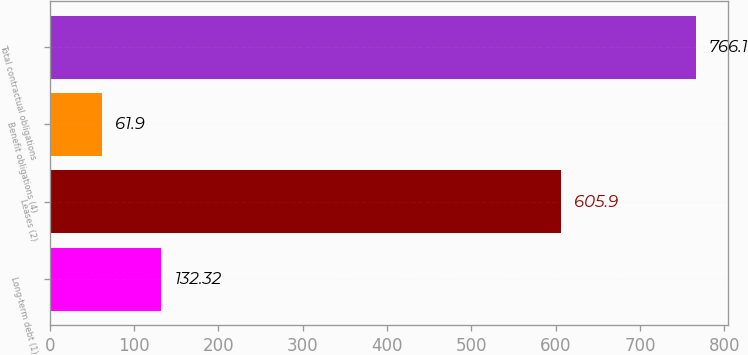Convert chart to OTSL. <chart><loc_0><loc_0><loc_500><loc_500><bar_chart><fcel>Long-term debt (1)<fcel>Leases (2)<fcel>Benefit obligations (4)<fcel>Total contractual obligations<nl><fcel>132.32<fcel>605.9<fcel>61.9<fcel>766.1<nl></chart> 